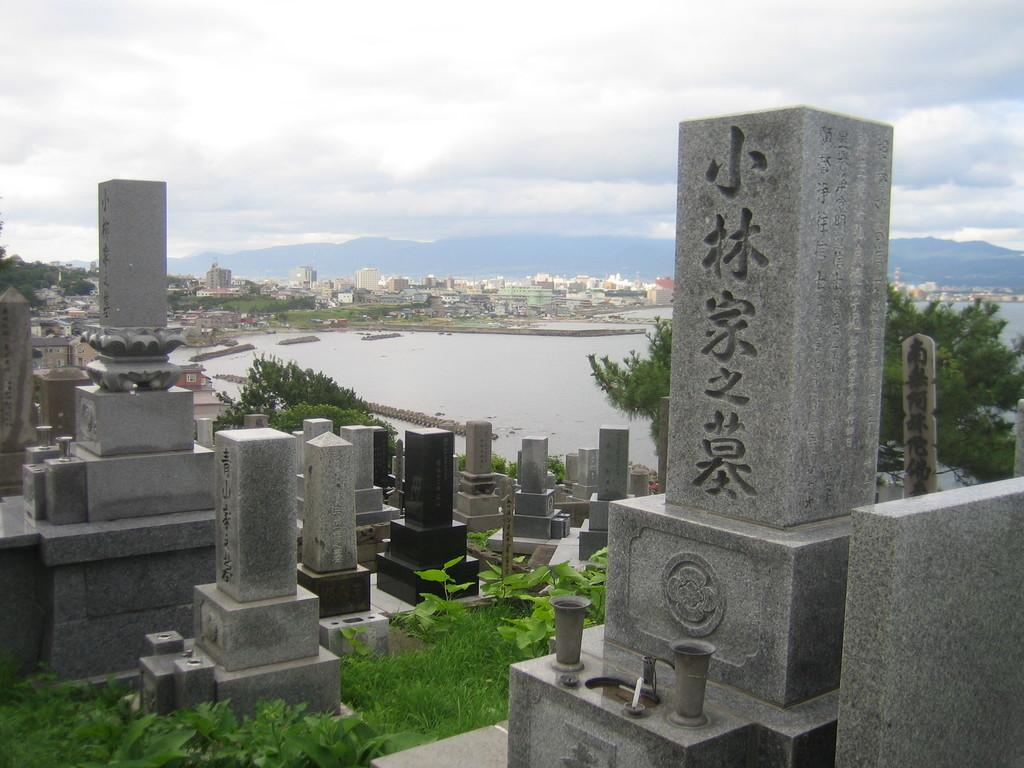What is the main feature in the middle of the image? There is a lake in the middle of the image. What else can be seen in the image besides the lake? There are buildings visible in the image, and the sky is visible at the top of the image. What is located in the foreground of the image? There is a group of cemetery and grass in the foreground of the image, along with plants. Can you tell me how many key are scattered around the lake in the image? There are no keys present in the image; it features a lake, buildings, sky, cemetery, grass, and plants. What type of ladybug can be seen interacting with the plants in the foreground of the image? There are no ladybugs present in the image; it features a lake, buildings, sky, cemetery, grass, and plants. 